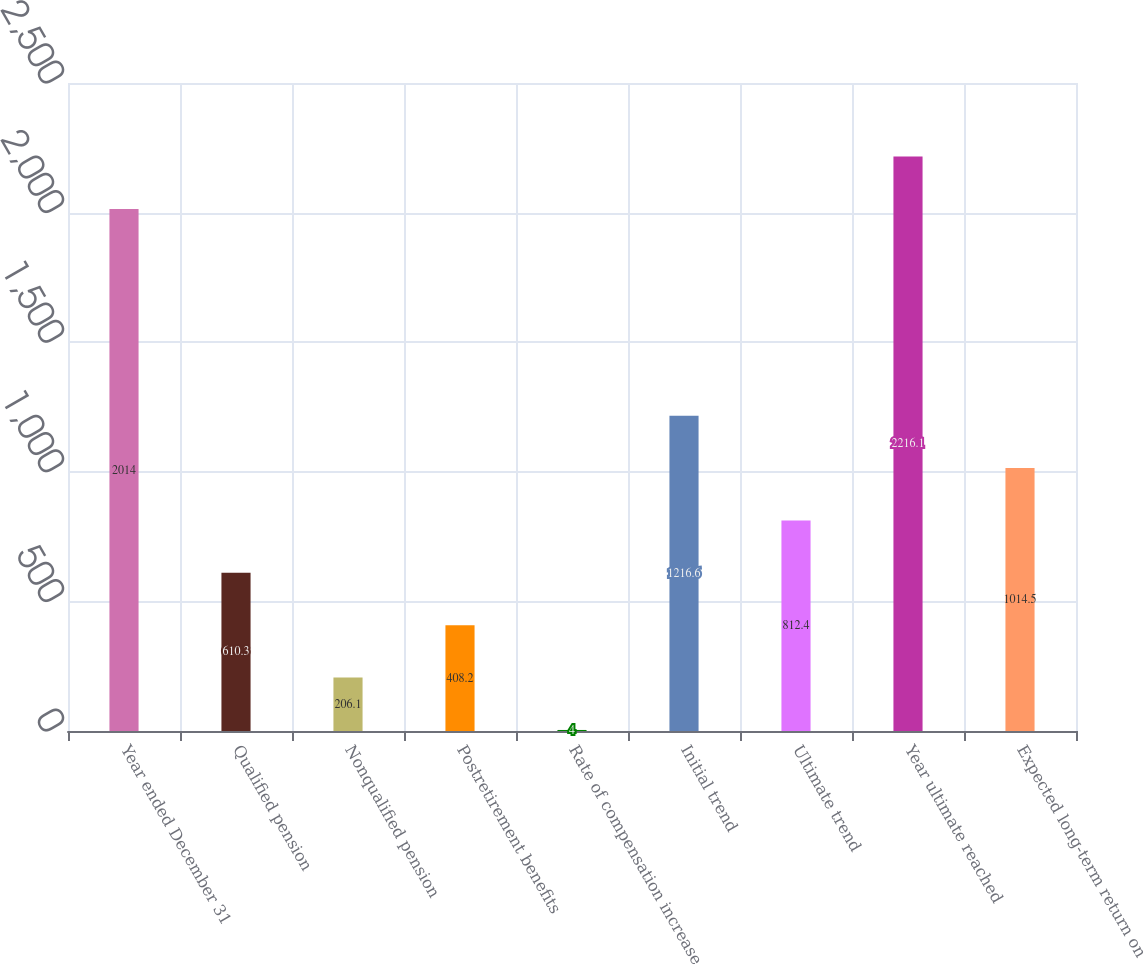Convert chart. <chart><loc_0><loc_0><loc_500><loc_500><bar_chart><fcel>Year ended December 31<fcel>Qualified pension<fcel>Nonqualified pension<fcel>Postretirement benefits<fcel>Rate of compensation increase<fcel>Initial trend<fcel>Ultimate trend<fcel>Year ultimate reached<fcel>Expected long-term return on<nl><fcel>2014<fcel>610.3<fcel>206.1<fcel>408.2<fcel>4<fcel>1216.6<fcel>812.4<fcel>2216.1<fcel>1014.5<nl></chart> 